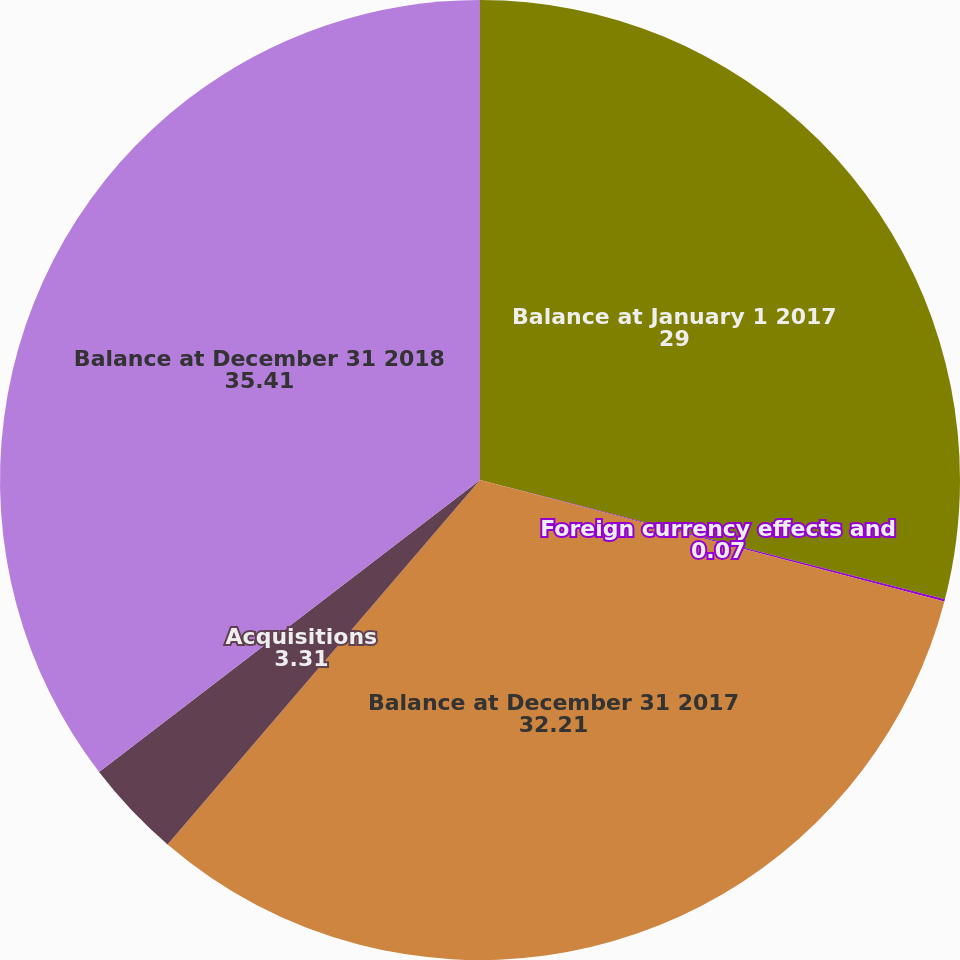Convert chart to OTSL. <chart><loc_0><loc_0><loc_500><loc_500><pie_chart><fcel>Balance at January 1 2017<fcel>Foreign currency effects and<fcel>Balance at December 31 2017<fcel>Acquisitions<fcel>Balance at December 31 2018<nl><fcel>29.0%<fcel>0.07%<fcel>32.21%<fcel>3.31%<fcel>35.41%<nl></chart> 